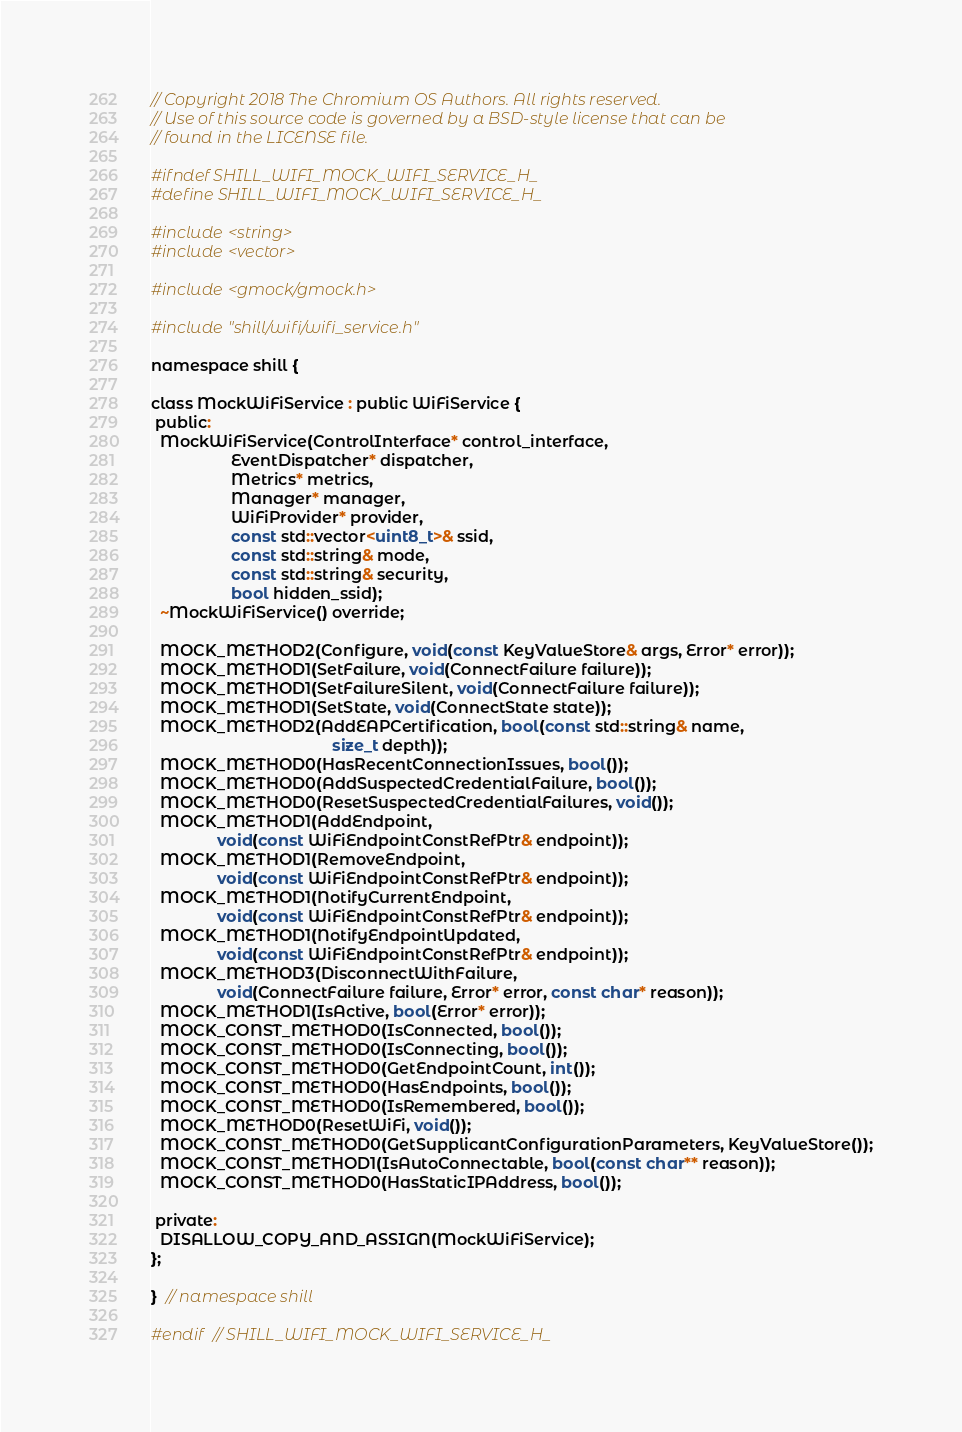Convert code to text. <code><loc_0><loc_0><loc_500><loc_500><_C_>// Copyright 2018 The Chromium OS Authors. All rights reserved.
// Use of this source code is governed by a BSD-style license that can be
// found in the LICENSE file.

#ifndef SHILL_WIFI_MOCK_WIFI_SERVICE_H_
#define SHILL_WIFI_MOCK_WIFI_SERVICE_H_

#include <string>
#include <vector>

#include <gmock/gmock.h>

#include "shill/wifi/wifi_service.h"

namespace shill {

class MockWiFiService : public WiFiService {
 public:
  MockWiFiService(ControlInterface* control_interface,
                  EventDispatcher* dispatcher,
                  Metrics* metrics,
                  Manager* manager,
                  WiFiProvider* provider,
                  const std::vector<uint8_t>& ssid,
                  const std::string& mode,
                  const std::string& security,
                  bool hidden_ssid);
  ~MockWiFiService() override;

  MOCK_METHOD2(Configure, void(const KeyValueStore& args, Error* error));
  MOCK_METHOD1(SetFailure, void(ConnectFailure failure));
  MOCK_METHOD1(SetFailureSilent, void(ConnectFailure failure));
  MOCK_METHOD1(SetState, void(ConnectState state));
  MOCK_METHOD2(AddEAPCertification, bool(const std::string& name,
                                         size_t depth));
  MOCK_METHOD0(HasRecentConnectionIssues, bool());
  MOCK_METHOD0(AddSuspectedCredentialFailure, bool());
  MOCK_METHOD0(ResetSuspectedCredentialFailures, void());
  MOCK_METHOD1(AddEndpoint,
               void(const WiFiEndpointConstRefPtr& endpoint));
  MOCK_METHOD1(RemoveEndpoint,
               void(const WiFiEndpointConstRefPtr& endpoint));
  MOCK_METHOD1(NotifyCurrentEndpoint,
               void(const WiFiEndpointConstRefPtr& endpoint));
  MOCK_METHOD1(NotifyEndpointUpdated,
               void(const WiFiEndpointConstRefPtr& endpoint));
  MOCK_METHOD3(DisconnectWithFailure,
               void(ConnectFailure failure, Error* error, const char* reason));
  MOCK_METHOD1(IsActive, bool(Error* error));
  MOCK_CONST_METHOD0(IsConnected, bool());
  MOCK_CONST_METHOD0(IsConnecting, bool());
  MOCK_CONST_METHOD0(GetEndpointCount, int());
  MOCK_CONST_METHOD0(HasEndpoints, bool());
  MOCK_CONST_METHOD0(IsRemembered, bool());
  MOCK_METHOD0(ResetWiFi, void());
  MOCK_CONST_METHOD0(GetSupplicantConfigurationParameters, KeyValueStore());
  MOCK_CONST_METHOD1(IsAutoConnectable, bool(const char** reason));
  MOCK_CONST_METHOD0(HasStaticIPAddress, bool());

 private:
  DISALLOW_COPY_AND_ASSIGN(MockWiFiService);
};

}  // namespace shill

#endif  // SHILL_WIFI_MOCK_WIFI_SERVICE_H_
</code> 